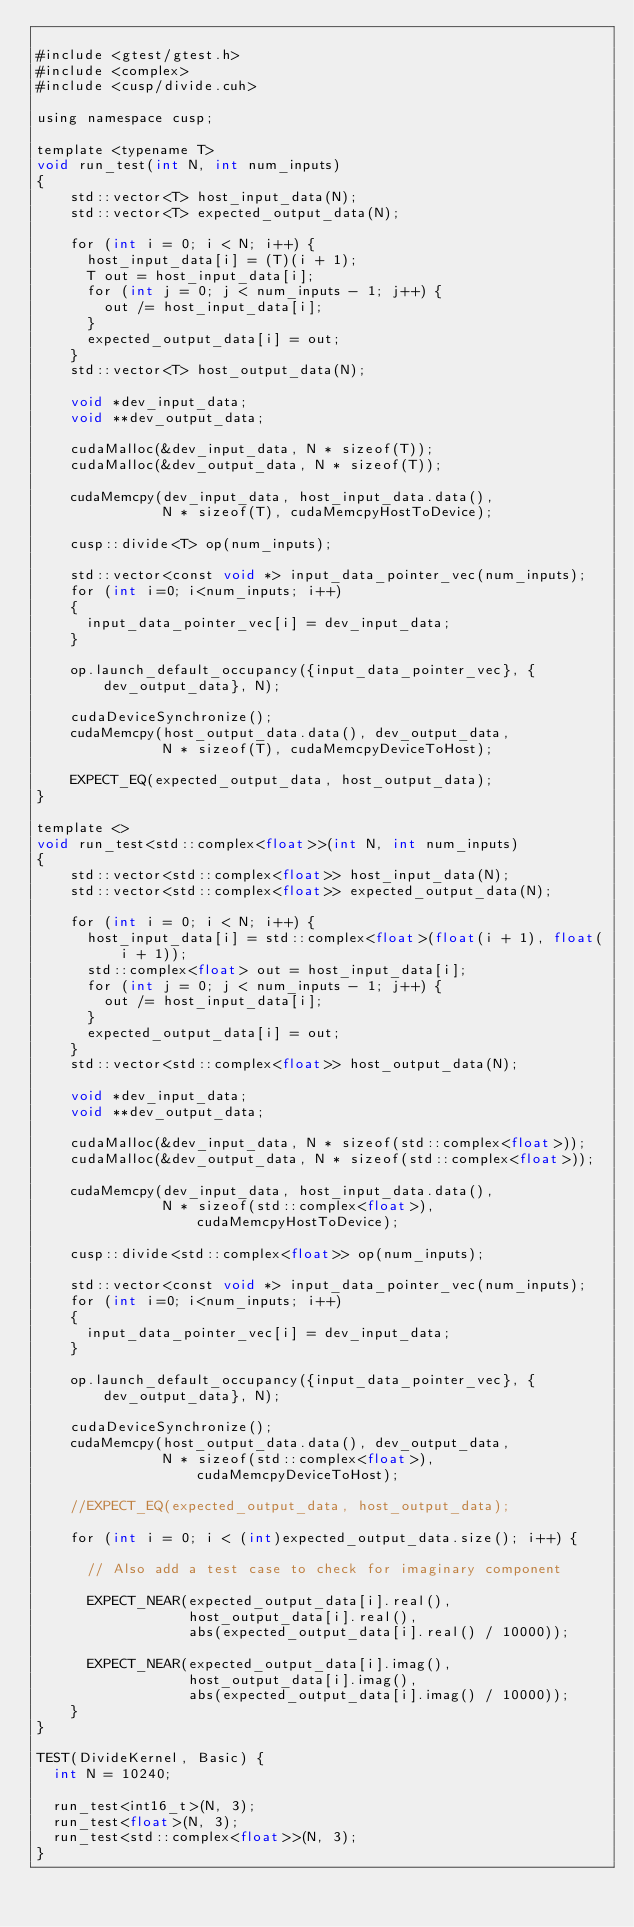Convert code to text. <code><loc_0><loc_0><loc_500><loc_500><_Cuda_>
#include <gtest/gtest.h>
#include <complex>
#include <cusp/divide.cuh>

using namespace cusp;

template <typename T> 
void run_test(int N, int num_inputs)
{
    std::vector<T> host_input_data(N);
    std::vector<T> expected_output_data(N);

    for (int i = 0; i < N; i++) {
      host_input_data[i] = (T)(i + 1);
      T out = host_input_data[i];
      for (int j = 0; j < num_inputs - 1; j++) {
        out /= host_input_data[i];
      }
      expected_output_data[i] = out;
    }
    std::vector<T> host_output_data(N);
  
    void *dev_input_data;
    void **dev_output_data;
  
    cudaMalloc(&dev_input_data, N * sizeof(T));
    cudaMalloc(&dev_output_data, N * sizeof(T));

    cudaMemcpy(dev_input_data, host_input_data.data(),
               N * sizeof(T), cudaMemcpyHostToDevice);
  
    cusp::divide<T> op(num_inputs);

    std::vector<const void *> input_data_pointer_vec(num_inputs);
    for (int i=0; i<num_inputs; i++)
    {
      input_data_pointer_vec[i] = dev_input_data;
    }

    op.launch_default_occupancy({input_data_pointer_vec}, {dev_output_data}, N);
  
    cudaDeviceSynchronize();
    cudaMemcpy(host_output_data.data(), dev_output_data,
               N * sizeof(T), cudaMemcpyDeviceToHost);
  
    EXPECT_EQ(expected_output_data, host_output_data);
}

template <> 
void run_test<std::complex<float>>(int N, int num_inputs)
{
    std::vector<std::complex<float>> host_input_data(N);
    std::vector<std::complex<float>> expected_output_data(N);

    for (int i = 0; i < N; i++) {
      host_input_data[i] = std::complex<float>(float(i + 1), float(i + 1));
      std::complex<float> out = host_input_data[i];
      for (int j = 0; j < num_inputs - 1; j++) {
        out /= host_input_data[i];
      }
      expected_output_data[i] = out;
    }
    std::vector<std::complex<float>> host_output_data(N);
  
    void *dev_input_data;
    void **dev_output_data;
  
    cudaMalloc(&dev_input_data, N * sizeof(std::complex<float>));
    cudaMalloc(&dev_output_data, N * sizeof(std::complex<float>));

    cudaMemcpy(dev_input_data, host_input_data.data(),
               N * sizeof(std::complex<float>), cudaMemcpyHostToDevice);
  
    cusp::divide<std::complex<float>> op(num_inputs);

    std::vector<const void *> input_data_pointer_vec(num_inputs);
    for (int i=0; i<num_inputs; i++)
    {
      input_data_pointer_vec[i] = dev_input_data;
    }

    op.launch_default_occupancy({input_data_pointer_vec}, {dev_output_data}, N);
  
    cudaDeviceSynchronize();
    cudaMemcpy(host_output_data.data(), dev_output_data,
               N * sizeof(std::complex<float>), cudaMemcpyDeviceToHost);
  
    //EXPECT_EQ(expected_output_data, host_output_data);

    for (int i = 0; i < (int)expected_output_data.size(); i++) {

      // Also add a test case to check for imaginary component

      EXPECT_NEAR(expected_output_data[i].real(),
                  host_output_data[i].real(),
                  abs(expected_output_data[i].real() / 10000));

      EXPECT_NEAR(expected_output_data[i].imag(),
                  host_output_data[i].imag(),
                  abs(expected_output_data[i].imag() / 10000));
    }
}

TEST(DivideKernel, Basic) {
  int N = 10240;

  run_test<int16_t>(N, 3);
  run_test<float>(N, 3);
  run_test<std::complex<float>>(N, 3);
}</code> 